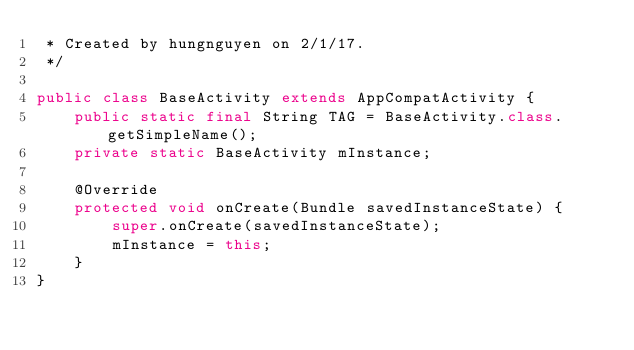Convert code to text. <code><loc_0><loc_0><loc_500><loc_500><_Java_> * Created by hungnguyen on 2/1/17.
 */

public class BaseActivity extends AppCompatActivity {
    public static final String TAG = BaseActivity.class.getSimpleName();
    private static BaseActivity mInstance;

    @Override
    protected void onCreate(Bundle savedInstanceState) {
        super.onCreate(savedInstanceState);
        mInstance = this;
    }
}
</code> 